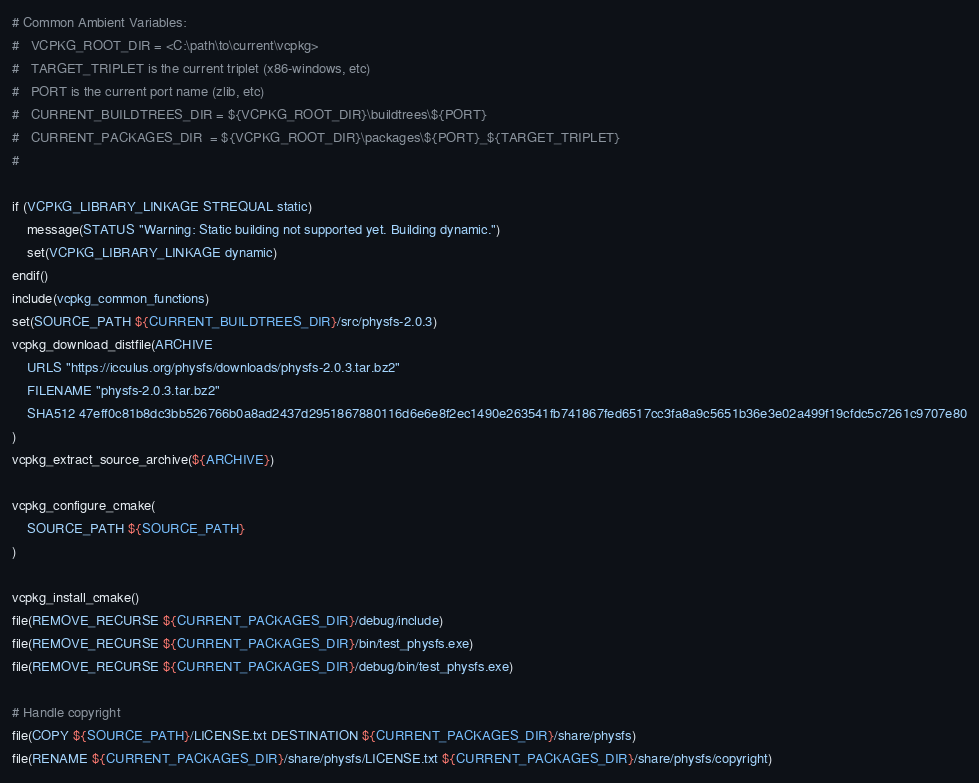Convert code to text. <code><loc_0><loc_0><loc_500><loc_500><_CMake_># Common Ambient Variables:
#   VCPKG_ROOT_DIR = <C:\path\to\current\vcpkg>
#   TARGET_TRIPLET is the current triplet (x86-windows, etc)
#   PORT is the current port name (zlib, etc)
#   CURRENT_BUILDTREES_DIR = ${VCPKG_ROOT_DIR}\buildtrees\${PORT}
#   CURRENT_PACKAGES_DIR  = ${VCPKG_ROOT_DIR}\packages\${PORT}_${TARGET_TRIPLET}
#

if (VCPKG_LIBRARY_LINKAGE STREQUAL static)
    message(STATUS "Warning: Static building not supported yet. Building dynamic.")
    set(VCPKG_LIBRARY_LINKAGE dynamic)
endif()
include(vcpkg_common_functions)
set(SOURCE_PATH ${CURRENT_BUILDTREES_DIR}/src/physfs-2.0.3)
vcpkg_download_distfile(ARCHIVE
    URLS "https://icculus.org/physfs/downloads/physfs-2.0.3.tar.bz2"
    FILENAME "physfs-2.0.3.tar.bz2"
    SHA512 47eff0c81b8dc3bb526766b0a8ad2437d2951867880116d6e6e8f2ec1490e263541fb741867fed6517cc3fa8a9c5651b36e3e02a499f19cfdc5c7261c9707e80
)
vcpkg_extract_source_archive(${ARCHIVE})

vcpkg_configure_cmake(
    SOURCE_PATH ${SOURCE_PATH}
)

vcpkg_install_cmake()
file(REMOVE_RECURSE ${CURRENT_PACKAGES_DIR}/debug/include)
file(REMOVE_RECURSE ${CURRENT_PACKAGES_DIR}/bin/test_physfs.exe)
file(REMOVE_RECURSE ${CURRENT_PACKAGES_DIR}/debug/bin/test_physfs.exe)

# Handle copyright
file(COPY ${SOURCE_PATH}/LICENSE.txt DESTINATION ${CURRENT_PACKAGES_DIR}/share/physfs)
file(RENAME ${CURRENT_PACKAGES_DIR}/share/physfs/LICENSE.txt ${CURRENT_PACKAGES_DIR}/share/physfs/copyright)
</code> 